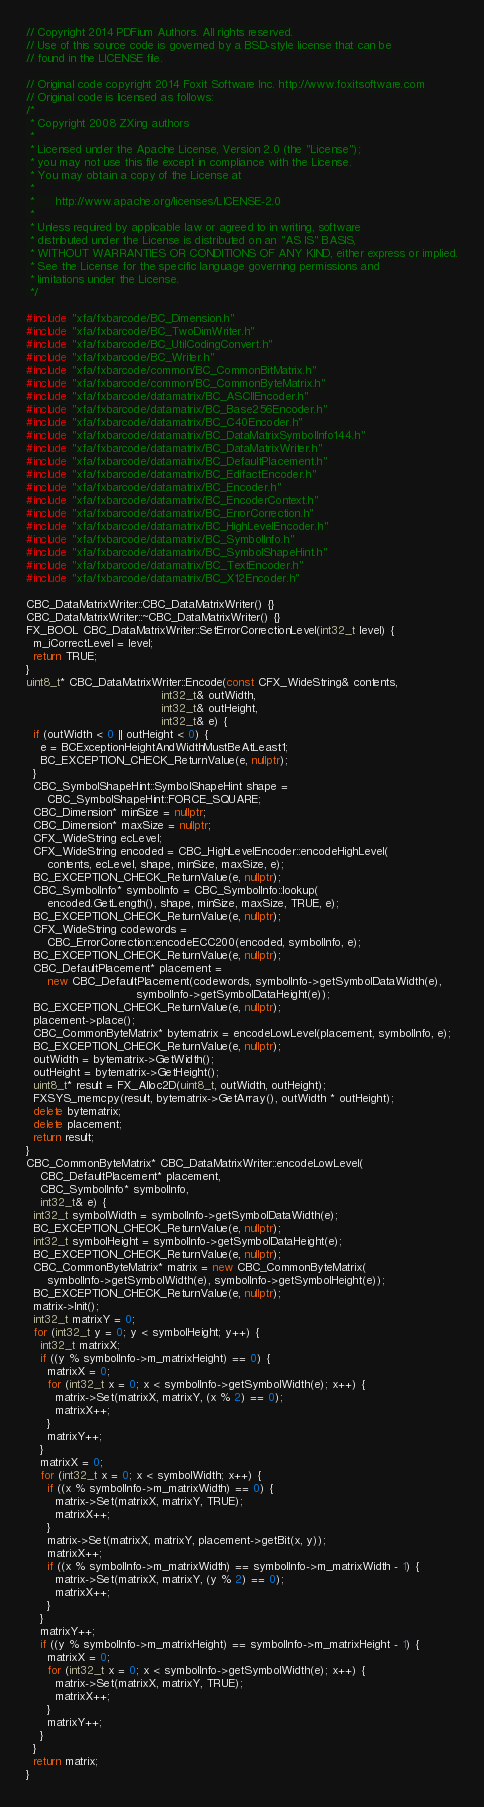Convert code to text. <code><loc_0><loc_0><loc_500><loc_500><_C++_>// Copyright 2014 PDFium Authors. All rights reserved.
// Use of this source code is governed by a BSD-style license that can be
// found in the LICENSE file.

// Original code copyright 2014 Foxit Software Inc. http://www.foxitsoftware.com
// Original code is licensed as follows:
/*
 * Copyright 2008 ZXing authors
 *
 * Licensed under the Apache License, Version 2.0 (the "License");
 * you may not use this file except in compliance with the License.
 * You may obtain a copy of the License at
 *
 *      http://www.apache.org/licenses/LICENSE-2.0
 *
 * Unless required by applicable law or agreed to in writing, software
 * distributed under the License is distributed on an "AS IS" BASIS,
 * WITHOUT WARRANTIES OR CONDITIONS OF ANY KIND, either express or implied.
 * See the License for the specific language governing permissions and
 * limitations under the License.
 */

#include "xfa/fxbarcode/BC_Dimension.h"
#include "xfa/fxbarcode/BC_TwoDimWriter.h"
#include "xfa/fxbarcode/BC_UtilCodingConvert.h"
#include "xfa/fxbarcode/BC_Writer.h"
#include "xfa/fxbarcode/common/BC_CommonBitMatrix.h"
#include "xfa/fxbarcode/common/BC_CommonByteMatrix.h"
#include "xfa/fxbarcode/datamatrix/BC_ASCIIEncoder.h"
#include "xfa/fxbarcode/datamatrix/BC_Base256Encoder.h"
#include "xfa/fxbarcode/datamatrix/BC_C40Encoder.h"
#include "xfa/fxbarcode/datamatrix/BC_DataMatrixSymbolInfo144.h"
#include "xfa/fxbarcode/datamatrix/BC_DataMatrixWriter.h"
#include "xfa/fxbarcode/datamatrix/BC_DefaultPlacement.h"
#include "xfa/fxbarcode/datamatrix/BC_EdifactEncoder.h"
#include "xfa/fxbarcode/datamatrix/BC_Encoder.h"
#include "xfa/fxbarcode/datamatrix/BC_EncoderContext.h"
#include "xfa/fxbarcode/datamatrix/BC_ErrorCorrection.h"
#include "xfa/fxbarcode/datamatrix/BC_HighLevelEncoder.h"
#include "xfa/fxbarcode/datamatrix/BC_SymbolInfo.h"
#include "xfa/fxbarcode/datamatrix/BC_SymbolShapeHint.h"
#include "xfa/fxbarcode/datamatrix/BC_TextEncoder.h"
#include "xfa/fxbarcode/datamatrix/BC_X12Encoder.h"

CBC_DataMatrixWriter::CBC_DataMatrixWriter() {}
CBC_DataMatrixWriter::~CBC_DataMatrixWriter() {}
FX_BOOL CBC_DataMatrixWriter::SetErrorCorrectionLevel(int32_t level) {
  m_iCorrectLevel = level;
  return TRUE;
}
uint8_t* CBC_DataMatrixWriter::Encode(const CFX_WideString& contents,
                                      int32_t& outWidth,
                                      int32_t& outHeight,
                                      int32_t& e) {
  if (outWidth < 0 || outHeight < 0) {
    e = BCExceptionHeightAndWidthMustBeAtLeast1;
    BC_EXCEPTION_CHECK_ReturnValue(e, nullptr);
  }
  CBC_SymbolShapeHint::SymbolShapeHint shape =
      CBC_SymbolShapeHint::FORCE_SQUARE;
  CBC_Dimension* minSize = nullptr;
  CBC_Dimension* maxSize = nullptr;
  CFX_WideString ecLevel;
  CFX_WideString encoded = CBC_HighLevelEncoder::encodeHighLevel(
      contents, ecLevel, shape, minSize, maxSize, e);
  BC_EXCEPTION_CHECK_ReturnValue(e, nullptr);
  CBC_SymbolInfo* symbolInfo = CBC_SymbolInfo::lookup(
      encoded.GetLength(), shape, minSize, maxSize, TRUE, e);
  BC_EXCEPTION_CHECK_ReturnValue(e, nullptr);
  CFX_WideString codewords =
      CBC_ErrorCorrection::encodeECC200(encoded, symbolInfo, e);
  BC_EXCEPTION_CHECK_ReturnValue(e, nullptr);
  CBC_DefaultPlacement* placement =
      new CBC_DefaultPlacement(codewords, symbolInfo->getSymbolDataWidth(e),
                               symbolInfo->getSymbolDataHeight(e));
  BC_EXCEPTION_CHECK_ReturnValue(e, nullptr);
  placement->place();
  CBC_CommonByteMatrix* bytematrix = encodeLowLevel(placement, symbolInfo, e);
  BC_EXCEPTION_CHECK_ReturnValue(e, nullptr);
  outWidth = bytematrix->GetWidth();
  outHeight = bytematrix->GetHeight();
  uint8_t* result = FX_Alloc2D(uint8_t, outWidth, outHeight);
  FXSYS_memcpy(result, bytematrix->GetArray(), outWidth * outHeight);
  delete bytematrix;
  delete placement;
  return result;
}
CBC_CommonByteMatrix* CBC_DataMatrixWriter::encodeLowLevel(
    CBC_DefaultPlacement* placement,
    CBC_SymbolInfo* symbolInfo,
    int32_t& e) {
  int32_t symbolWidth = symbolInfo->getSymbolDataWidth(e);
  BC_EXCEPTION_CHECK_ReturnValue(e, nullptr);
  int32_t symbolHeight = symbolInfo->getSymbolDataHeight(e);
  BC_EXCEPTION_CHECK_ReturnValue(e, nullptr);
  CBC_CommonByteMatrix* matrix = new CBC_CommonByteMatrix(
      symbolInfo->getSymbolWidth(e), symbolInfo->getSymbolHeight(e));
  BC_EXCEPTION_CHECK_ReturnValue(e, nullptr);
  matrix->Init();
  int32_t matrixY = 0;
  for (int32_t y = 0; y < symbolHeight; y++) {
    int32_t matrixX;
    if ((y % symbolInfo->m_matrixHeight) == 0) {
      matrixX = 0;
      for (int32_t x = 0; x < symbolInfo->getSymbolWidth(e); x++) {
        matrix->Set(matrixX, matrixY, (x % 2) == 0);
        matrixX++;
      }
      matrixY++;
    }
    matrixX = 0;
    for (int32_t x = 0; x < symbolWidth; x++) {
      if ((x % symbolInfo->m_matrixWidth) == 0) {
        matrix->Set(matrixX, matrixY, TRUE);
        matrixX++;
      }
      matrix->Set(matrixX, matrixY, placement->getBit(x, y));
      matrixX++;
      if ((x % symbolInfo->m_matrixWidth) == symbolInfo->m_matrixWidth - 1) {
        matrix->Set(matrixX, matrixY, (y % 2) == 0);
        matrixX++;
      }
    }
    matrixY++;
    if ((y % symbolInfo->m_matrixHeight) == symbolInfo->m_matrixHeight - 1) {
      matrixX = 0;
      for (int32_t x = 0; x < symbolInfo->getSymbolWidth(e); x++) {
        matrix->Set(matrixX, matrixY, TRUE);
        matrixX++;
      }
      matrixY++;
    }
  }
  return matrix;
}
</code> 